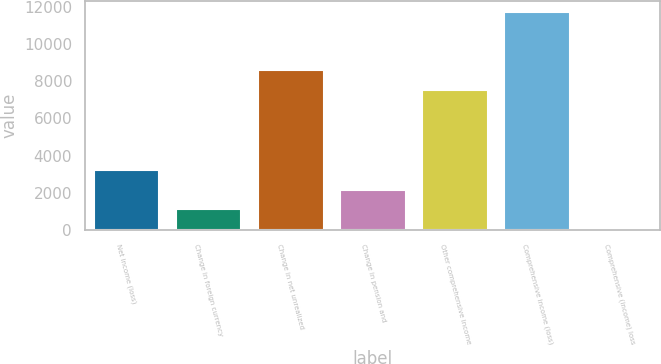Convert chart to OTSL. <chart><loc_0><loc_0><loc_500><loc_500><bar_chart><fcel>Net income (loss)<fcel>Change in foreign currency<fcel>Change in net unrealized<fcel>Change in pension and<fcel>Other comprehensive income<fcel>Comprehensive income (loss)<fcel>Comprehensive (income) loss<nl><fcel>3233.6<fcel>1105.2<fcel>8616.2<fcel>2169.4<fcel>7552<fcel>11706.2<fcel>41<nl></chart> 